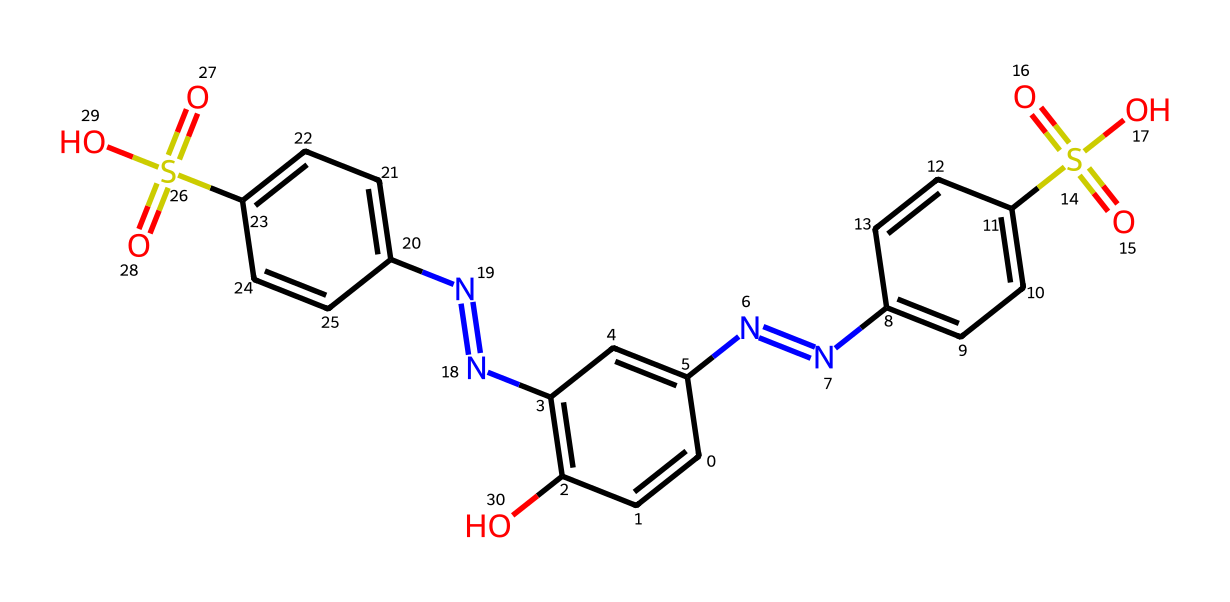What is the total number of carbon atoms in this compound? By examining the SMILES representation, we can count the number of carbon atoms in the structure. Each 'C' in the SMILES indicates a carbon atom; there are no hidden or implied carbon atoms because it's explicitly represented. Counting gives a total of 15 carbon atoms.
Answer: 15 How many nitrogen atoms are present in the chemical? In the SMILES string, the 'N' character stands for nitrogen, and we can count how many 'N' characters are present. There are four 'N' in the formula, meaning there are four nitrogen atoms.
Answer: 4 What type of functional groups can be identified in this structure? The functional groups can be identified by looking for distinctive elements or arrangements in the structure. The presence of 'S(=O)(=O)O' indicates sulfonic acid groups, while 'N=NC' connectivity suggests the presence of amines. Thus, the compound contains sulfonic acids and amines as functional groups.
Answer: sulfonic acids and amines Is this chemical a potential candidate for a carbene? To determine if the compound can exhibit carbene characteristics, we look for a carbon atom that is two bonds short of completing its tetravalency, which means it would form a double bond and a lone pair. Based on the structure, there are no such carbon atoms present.
Answer: No Which part of this molecule might contribute to its color in comic book ink? The aromatic rings, indicated by the alternating double bonds (C=C) implied in the structure, are typically responsible for color in organic compounds. The presence of multiple aromatic rings suggests a likely contribution to color.
Answer: Aromatic rings 